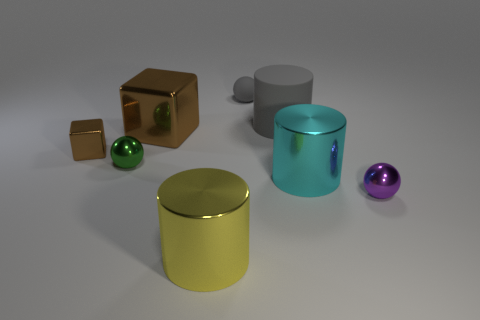Add 1 small yellow rubber objects. How many objects exist? 9 Subtract all spheres. How many objects are left? 5 Add 1 metal cubes. How many metal cubes are left? 3 Add 6 shiny cylinders. How many shiny cylinders exist? 8 Subtract 1 gray cylinders. How many objects are left? 7 Subtract all big yellow objects. Subtract all brown objects. How many objects are left? 5 